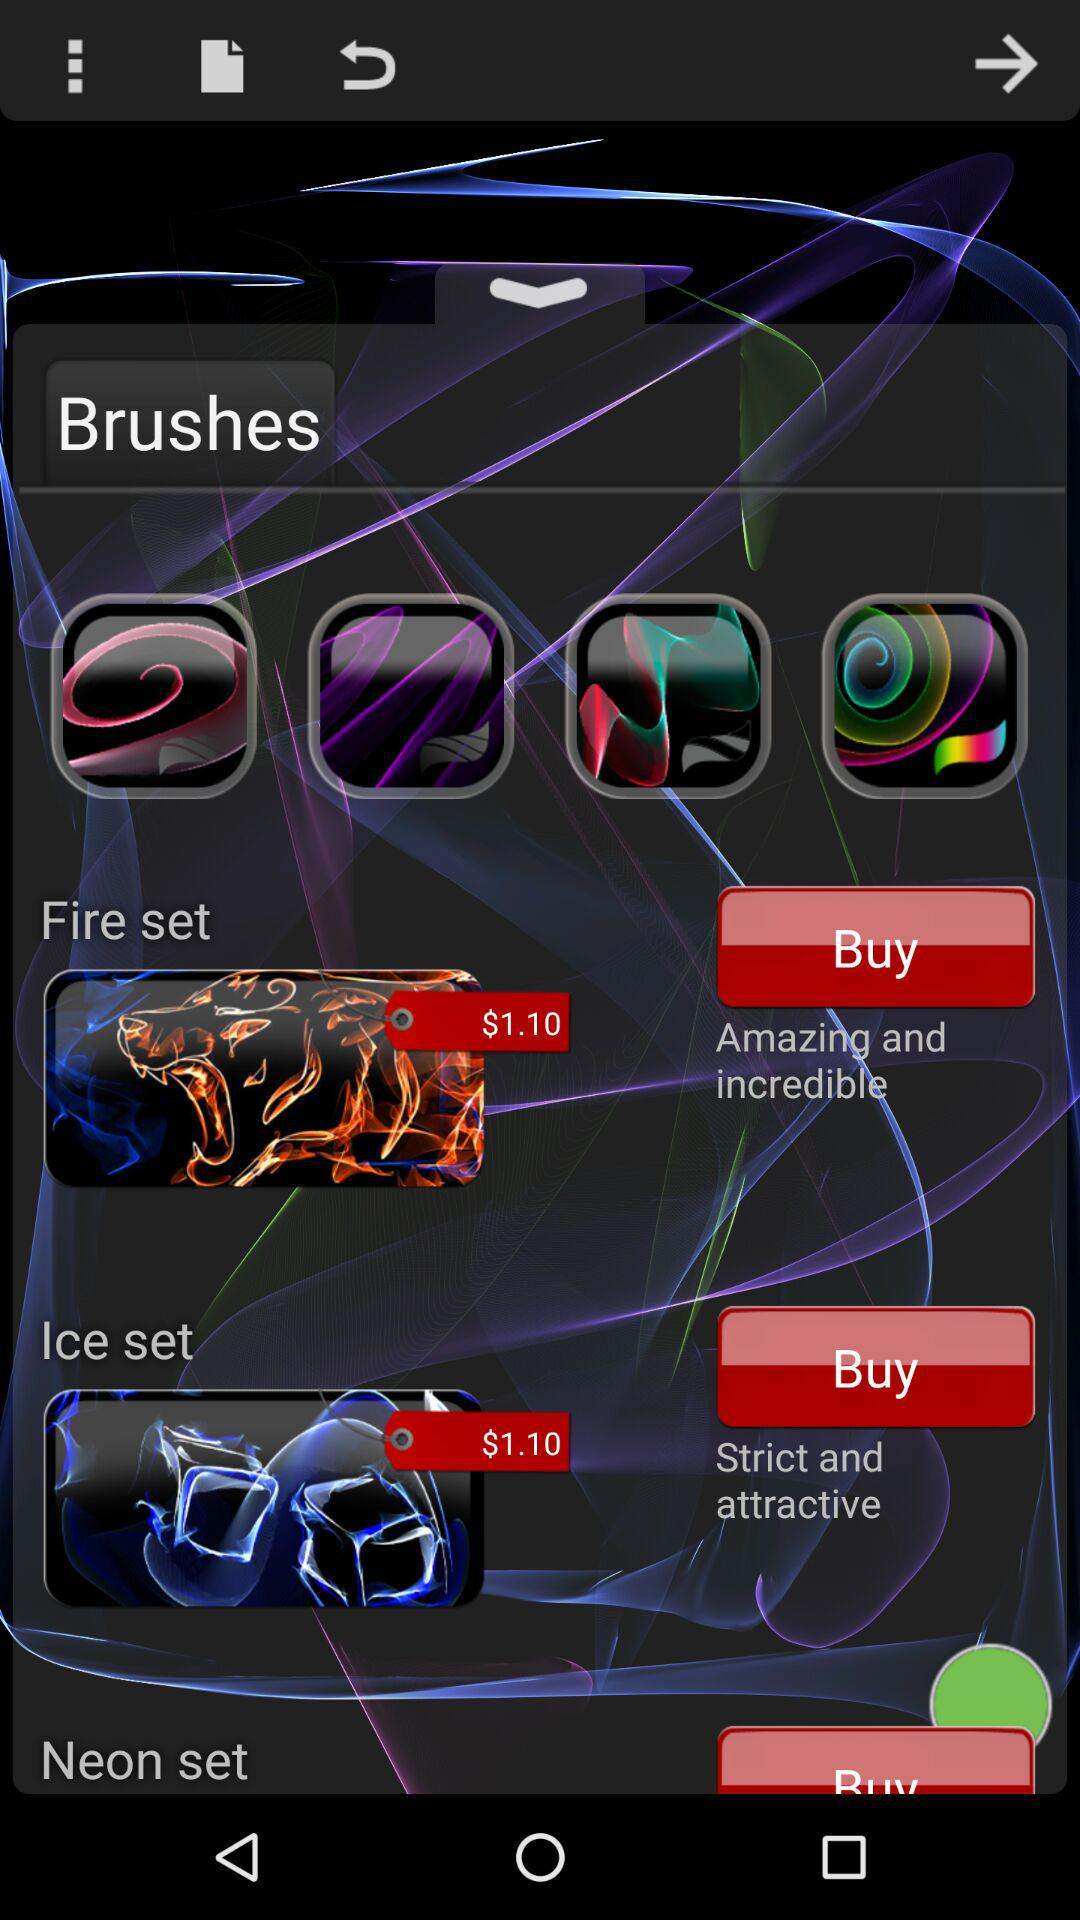What is the buying price of ice set brushes? The buying price of ice set brushes is $1.10. 